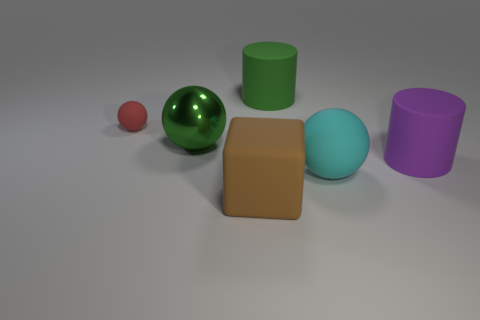Is there any other thing that has the same size as the red sphere?
Your response must be concise. No. What number of large objects have the same material as the red sphere?
Offer a very short reply. 4. Does the metallic sphere have the same color as the large object behind the large metal sphere?
Offer a terse response. Yes. What number of things are there?
Provide a short and direct response. 6. Is there a big sphere of the same color as the small rubber sphere?
Offer a very short reply. No. There is a matte cylinder that is on the right side of the large matte thing behind the matte sphere behind the big cyan rubber thing; what color is it?
Offer a very short reply. Purple. Is the brown block made of the same material as the large green object in front of the small red thing?
Offer a very short reply. No. What is the material of the red sphere?
Your answer should be very brief. Rubber. What is the material of the big thing that is the same color as the big metallic ball?
Your response must be concise. Rubber. What number of other things are made of the same material as the large cyan thing?
Your answer should be compact. 4. 